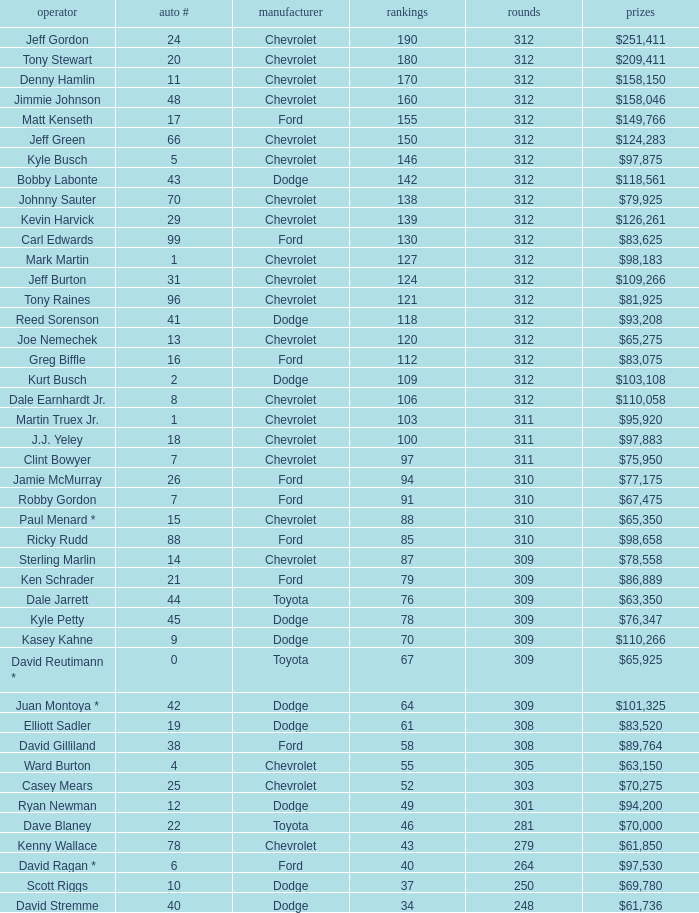What is the lowest number of laps for kyle petty with under 118 points? 309.0. 